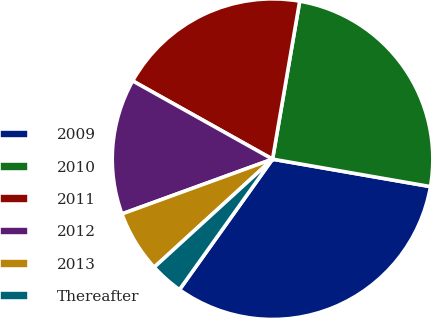Convert chart to OTSL. <chart><loc_0><loc_0><loc_500><loc_500><pie_chart><fcel>2009<fcel>2010<fcel>2011<fcel>2012<fcel>2013<fcel>Thereafter<nl><fcel>32.12%<fcel>25.03%<fcel>19.59%<fcel>13.67%<fcel>6.23%<fcel>3.36%<nl></chart> 